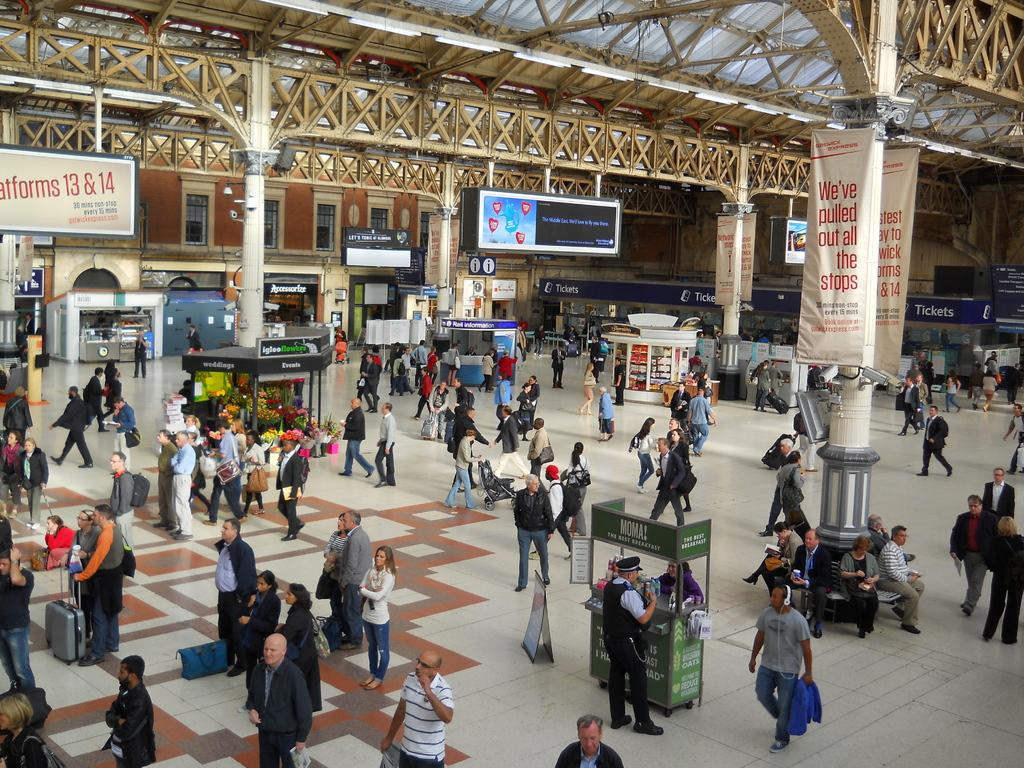<image>
Offer a succinct explanation of the picture presented. In a train station platform, a banner proclaims, "We've pulled out all the stops." 